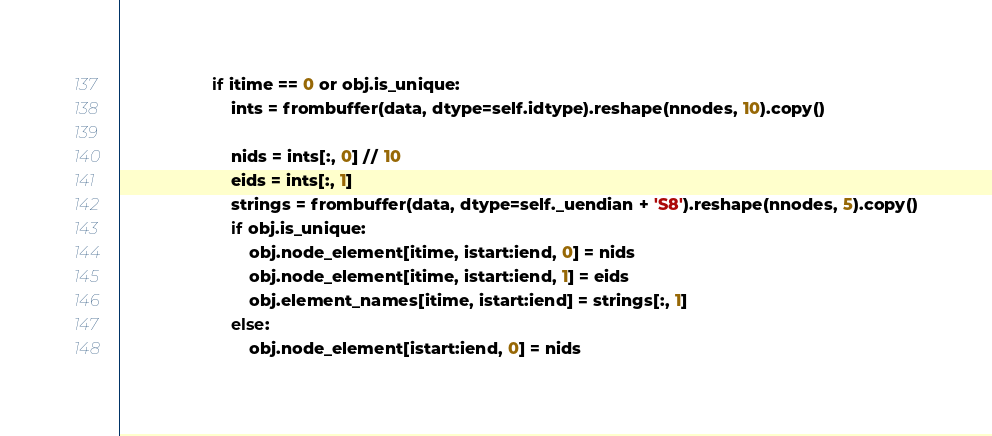<code> <loc_0><loc_0><loc_500><loc_500><_Python_>                    if itime == 0 or obj.is_unique:
                        ints = frombuffer(data, dtype=self.idtype).reshape(nnodes, 10).copy()

                        nids = ints[:, 0] // 10
                        eids = ints[:, 1]
                        strings = frombuffer(data, dtype=self._uendian + 'S8').reshape(nnodes, 5).copy()
                        if obj.is_unique:
                            obj.node_element[itime, istart:iend, 0] = nids
                            obj.node_element[itime, istart:iend, 1] = eids
                            obj.element_names[itime, istart:iend] = strings[:, 1]
                        else:
                            obj.node_element[istart:iend, 0] = nids</code> 